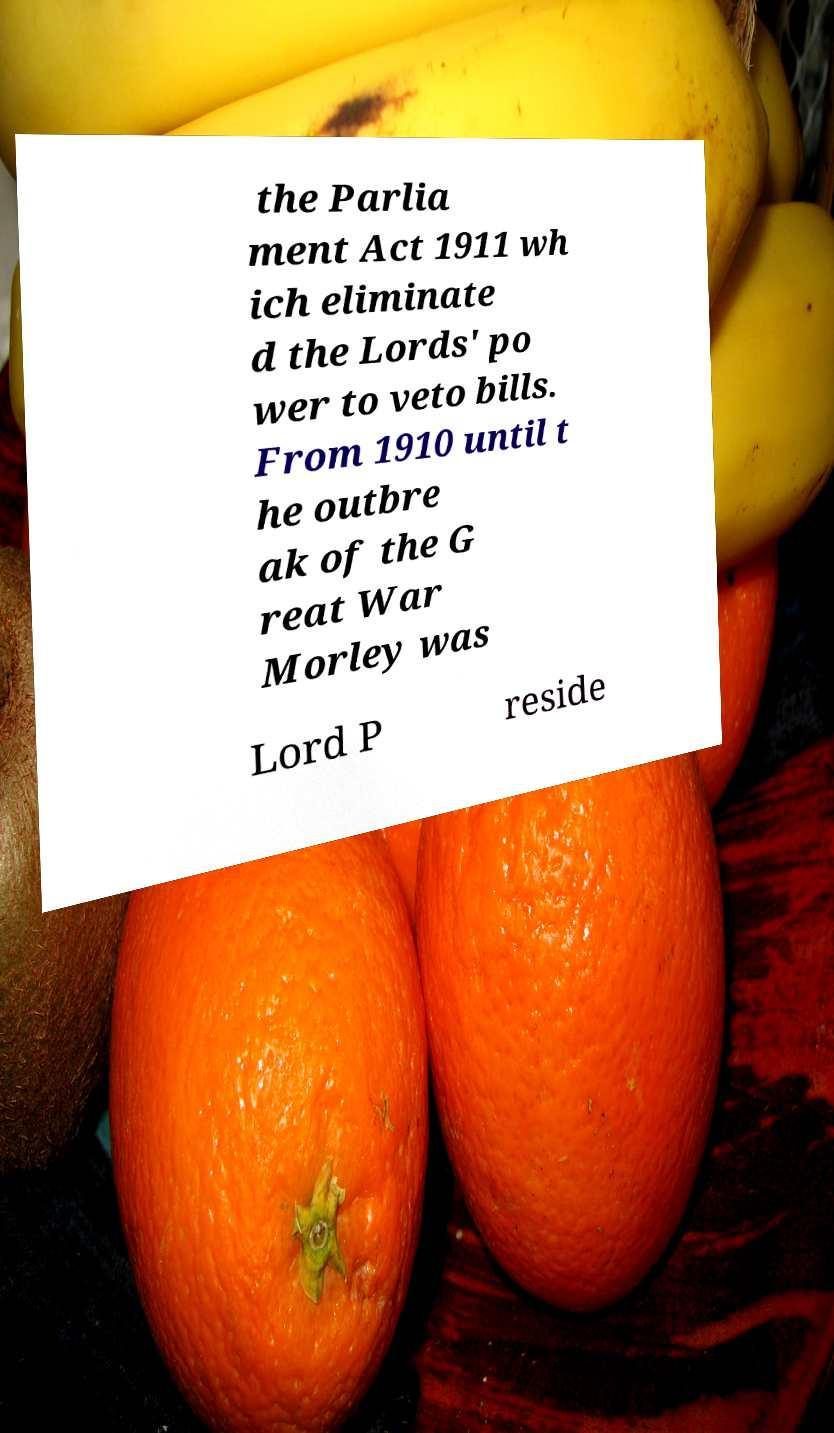Can you accurately transcribe the text from the provided image for me? the Parlia ment Act 1911 wh ich eliminate d the Lords' po wer to veto bills. From 1910 until t he outbre ak of the G reat War Morley was Lord P reside 